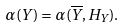Convert formula to latex. <formula><loc_0><loc_0><loc_500><loc_500>\alpha ( Y ) = \alpha ( \overline { Y } , H _ { Y } ) .</formula> 